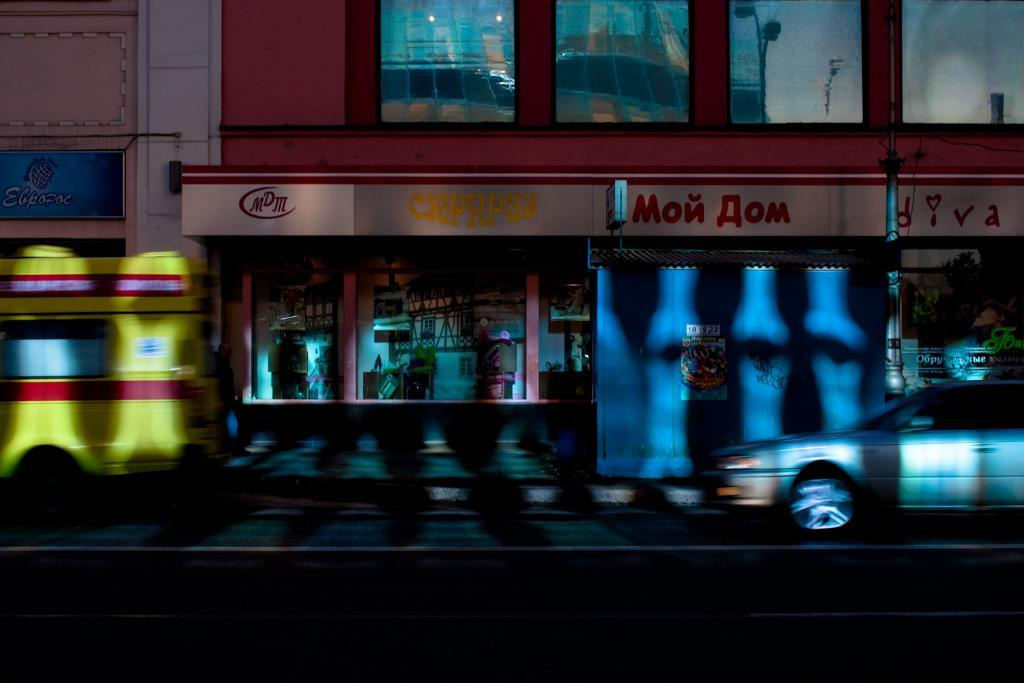What can be seen on the road in the image? There are vehicles on the road in the image. What is visible in the background of the image? There are buildings, a pole, and boards in the background. What type of wall can be seen in the image? There is no wall present in the image. What color is the skin of the person in the image? There is no person present in the image, so it is not possible to determine the color of their skin. 